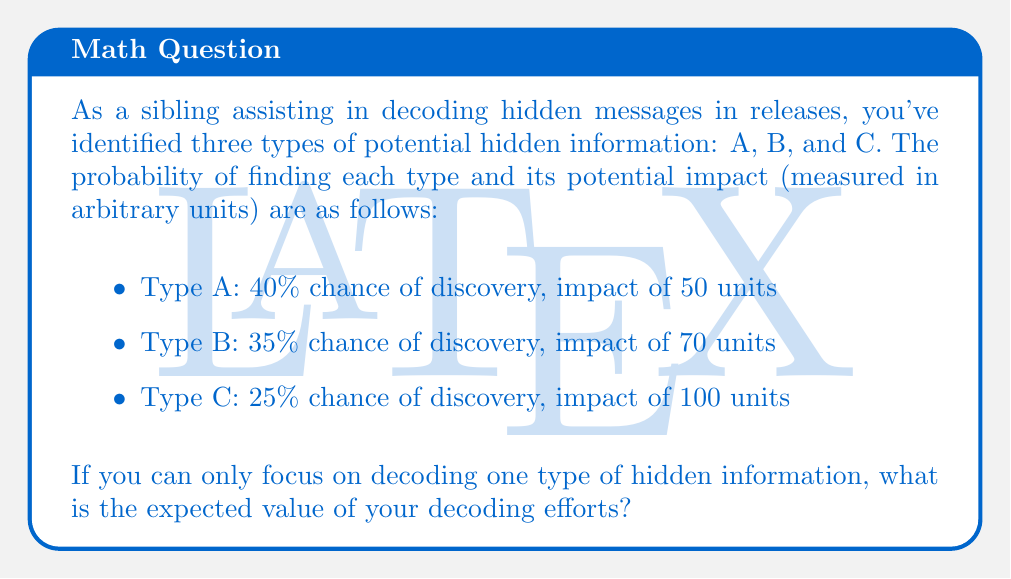Show me your answer to this math problem. To solve this problem, we need to calculate the expected value for each type of hidden information and then choose the highest value. The expected value is calculated by multiplying the probability of discovery by the potential impact.

Let's calculate the expected value for each type:

1. Type A:
   $$ EV_A = 0.40 \times 50 = 20 \text{ units} $$

2. Type B:
   $$ EV_B = 0.35 \times 70 = 24.5 \text{ units} $$

3. Type C:
   $$ EV_C = 0.25 \times 100 = 25 \text{ units} $$

The expected value of the decoding efforts is the highest value among these three options, which is Type C with 25 units.

This result means that focusing on decoding Type C hidden information, despite having the lowest probability of discovery, yields the highest expected value due to its significant potential impact.
Answer: The expected value of the decoding efforts is 25 units, achieved by focusing on Type C hidden information. 